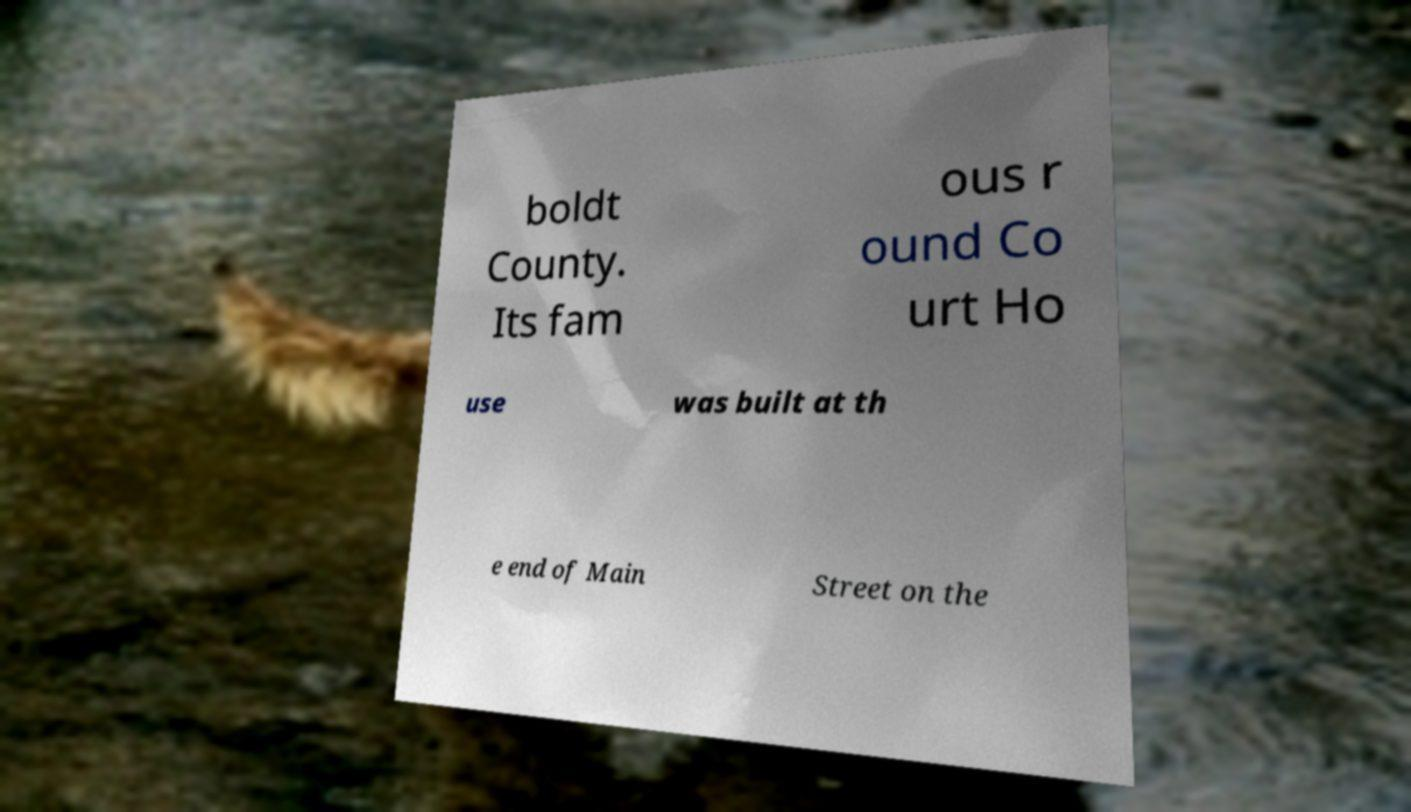Could you extract and type out the text from this image? boldt County. Its fam ous r ound Co urt Ho use was built at th e end of Main Street on the 